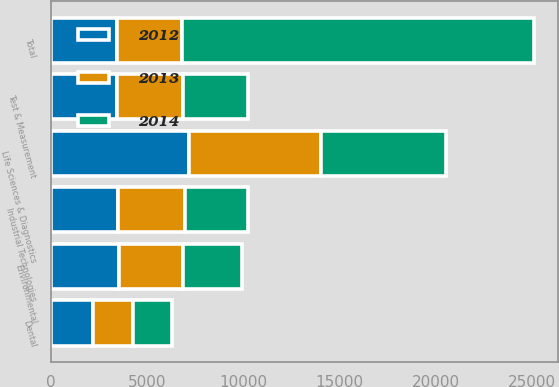<chart> <loc_0><loc_0><loc_500><loc_500><stacked_bar_chart><ecel><fcel>Test & Measurement<fcel>Environmental<fcel>Life Sciences & Diagnostics<fcel>Dental<fcel>Industrial Technologies<fcel>Total<nl><fcel>2012<fcel>3461.9<fcel>3547.3<fcel>7185.7<fcel>2193.1<fcel>3525.8<fcel>3424.9<nl><fcel>2013<fcel>3417.3<fcel>3316.9<fcel>6856.4<fcel>2094.9<fcel>3432.5<fcel>3424.9<nl><fcel>2014<fcel>3381<fcel>3063.5<fcel>6485.1<fcel>2022.9<fcel>3307.9<fcel>18260.4<nl></chart> 